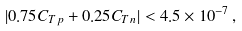<formula> <loc_0><loc_0><loc_500><loc_500>| 0 . 7 5 C _ { T p } + 0 . 2 5 C _ { T n } | < 4 . 5 \times 1 0 ^ { - 7 } \, ,</formula> 